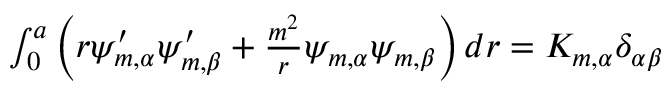<formula> <loc_0><loc_0><loc_500><loc_500>\begin{array} { r } { \int _ { 0 } ^ { a } \left ( r \psi _ { m , \alpha } ^ { \prime } \psi _ { m , \beta } ^ { \prime } + \frac { m ^ { 2 } } { r } \psi _ { m , \alpha } \psi _ { m , \beta } \right ) d r = K _ { m , \alpha } \delta _ { \alpha \beta } } \end{array}</formula> 